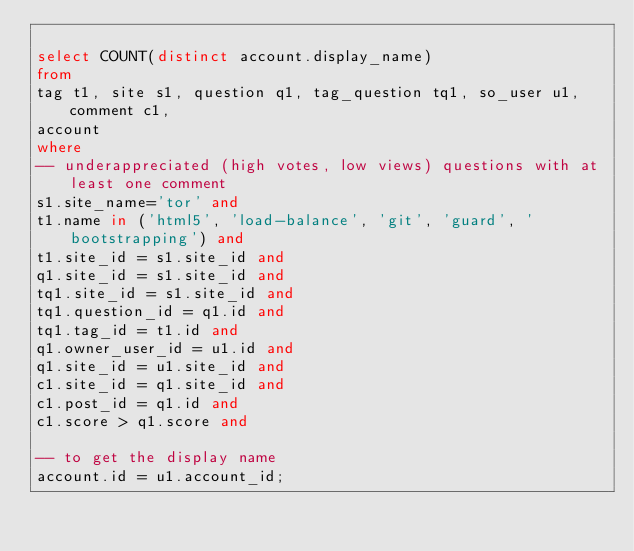Convert code to text. <code><loc_0><loc_0><loc_500><loc_500><_SQL_>
select COUNT(distinct account.display_name)
from
tag t1, site s1, question q1, tag_question tq1, so_user u1, comment c1,
account
where
-- underappreciated (high votes, low views) questions with at least one comment
s1.site_name='tor' and
t1.name in ('html5', 'load-balance', 'git', 'guard', 'bootstrapping') and
t1.site_id = s1.site_id and
q1.site_id = s1.site_id and
tq1.site_id = s1.site_id and
tq1.question_id = q1.id and
tq1.tag_id = t1.id and
q1.owner_user_id = u1.id and
q1.site_id = u1.site_id and
c1.site_id = q1.site_id and
c1.post_id = q1.id and
c1.score > q1.score and

-- to get the display name
account.id = u1.account_id;

</code> 